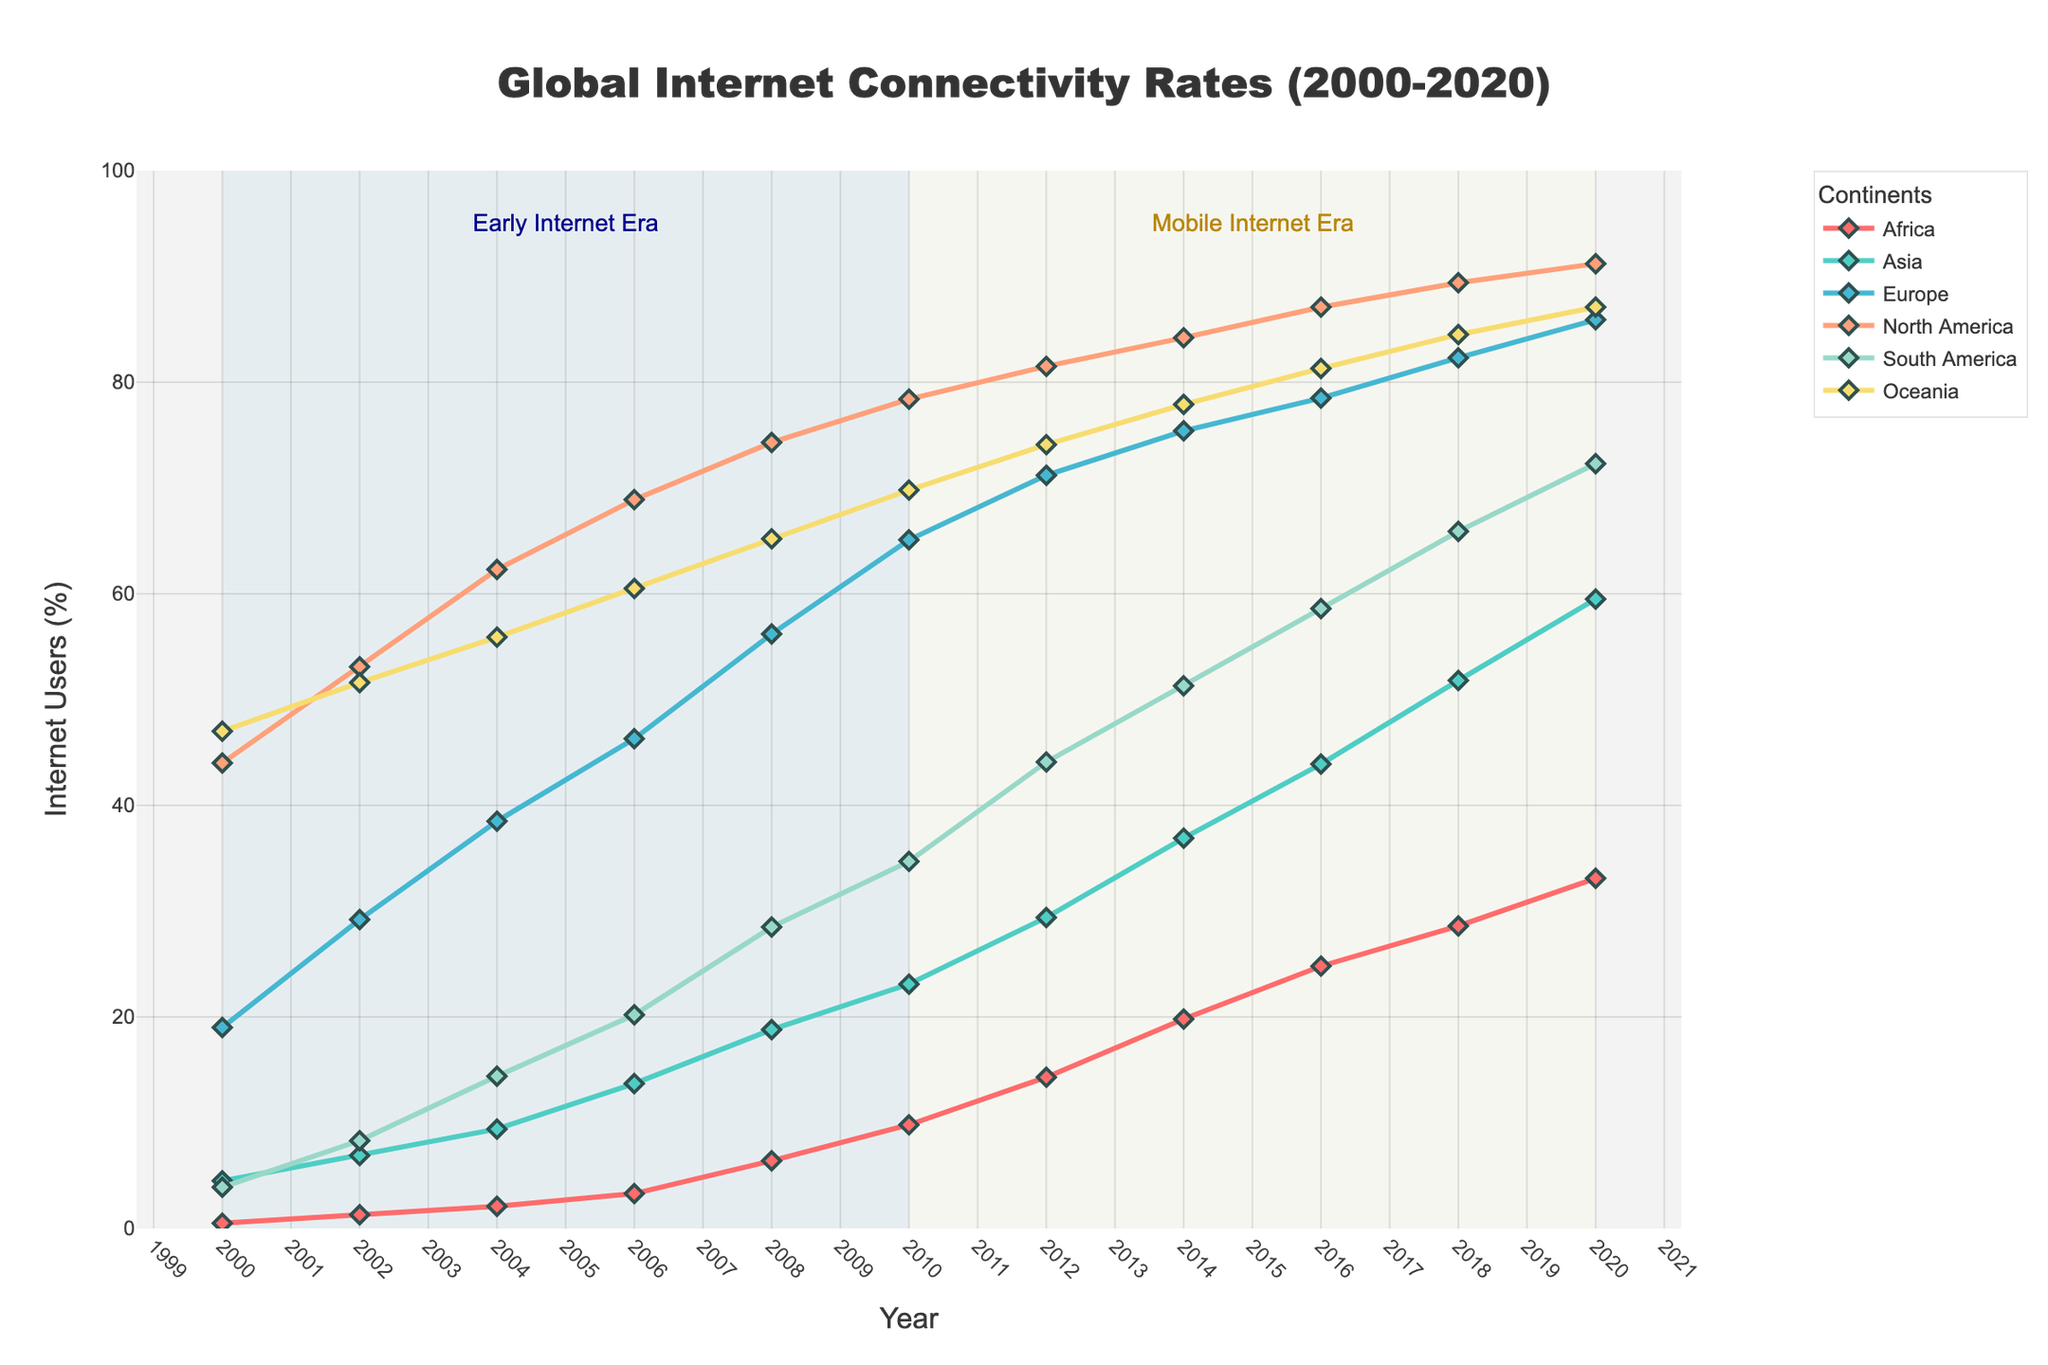What periods are highlighted in the figure? The figure contains two colored rectangular shapes highlighting specific periods. The period from 2000 to 2010 is shaded light blue and labeled "Early Internet Era". The period from 2010 to 2020 is shaded light yellow and labeled "Mobile Internet Era". These annotations help break down the timeline into significant eras in internet connectivity history.
Answer: Early Internet Era and Mobile Internet Era Which continent had the highest internet connectivity rate in 2020? To determine which continent had the highest connectivity rate in 2020, look at the final data points for each line representing the continents. In 2020, the red line representing North America reaches the top at around 91.2%. Hence, North America had the highest rate.
Answer: North America How has Africa's internet connectivity rate changed from 2000 to 2020? To track Africa's connectivity growth, observe the line representing Africa from 2000 to 2020. The rate increased from 0.5% in 2000 to 33.1% in 2020. This represents significant growth over the 20-year period.
Answer: Increased from 0.5% to 33.1% Which continent showed the most significant increase in internet connectivity rate between 2000 and 2020? To find the continent with the most significant increase, calculate the difference in connectivity from 2000 to 2020 for each continent. Africa increased by (33.1%-0.5%) = 32.6%, Asia by (59.5%-4.5%) = 55%, Europe by (85.9%-19%) = 66.9%, North America by (91.2%-44%) = 47.2%, South America by (72.3%-3.9%) = 68.4%, and Oceania by (87.1%-47%) = 40.1%. Europe showed the most significant increase of 66.9%.
Answer: Europe Which continent had a slower growth rate after 2010 compared to the previous decade? Compare the slopes of each line for the periods 2000-2010 and 2010-2020. Specifically, look at continents with less steep increases after 2010. Africa, for instance, increased significantly between 2000-2010 but the growth rate became more gradual from 2010-2020. Similarly, Europe had a more significant rise from 2000-2010 and a slower rise afterward. Therefore, Europe and Africa had slower growth rates after 2010 compared to the previous decade.
Answer: Europe and Africa What trend can be observed in the internet connectivity rates of Oceania from 2000 to 2020? To identify the trend in Oceania, follow the line marked for it from 2000 to 2020. The data points steadily increase every two years, illustrating a consistent upward trend from 47% in 2000 to 87.1% in 2020.
Answer: Consistent upward trend Compare the internet connectivity rate of Asia in 2006 with that of South America in 2008. Which was higher? Look at the y-values for Asia in 2006 and South America in 2008. In 2006, Asia's rate was 13.7%, while South America's rate in 2008 was 28.5%. Therefore, South America's rate in 2008 was higher.
Answer: South America in 2008 What's the difference in internet connectivity rates between Europe and Africa in 2014? Find the rates for Europe and Africa in 2014. For Europe, it was 75.4%, and for Africa, it was 19.8%. Subtract Africa's rate from Europe's: 75.4% - 19.8% = 55.6%.
Answer: 55.6% Which continents had internet connectivity rates above 80% by 2018? Look at the 2018 data points and see which continents' values are above the 80% mark. Europe (82.3%), North America (89.4%), and Oceania (84.5%) had rates above 80%.
Answer: Europe, North America, and Oceania 